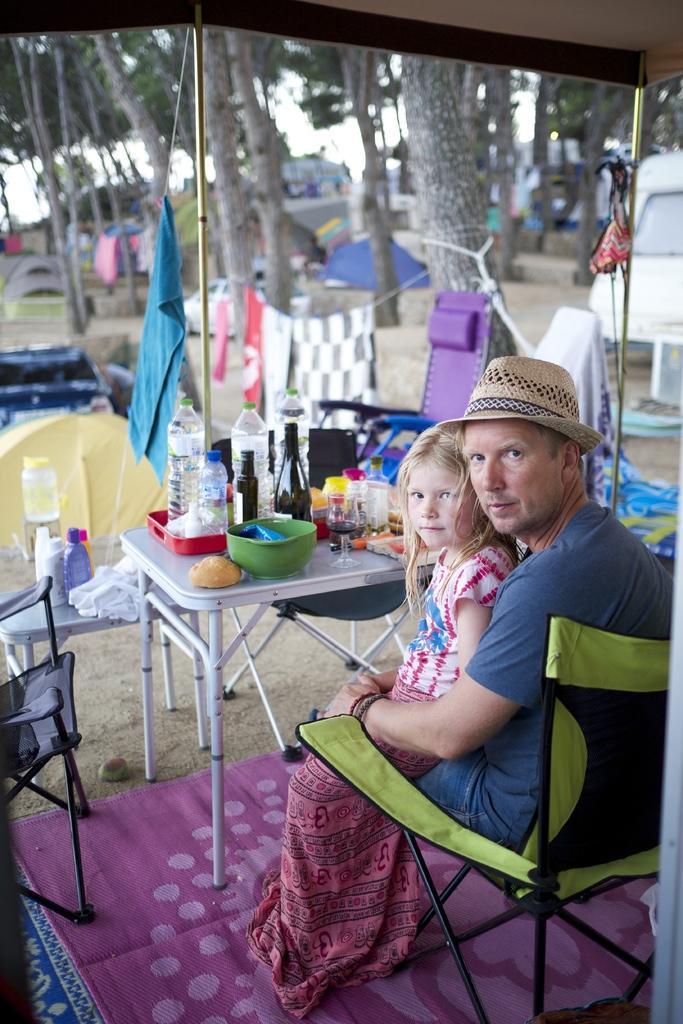Please provide a concise description of this image. On the right side of the image there is a man and a girl are sitting on the chair. In front of these people there is a table, on that few bottles, bowl and glasses are placed. In the background I can see trees. On the left side of the image there is a chair. 